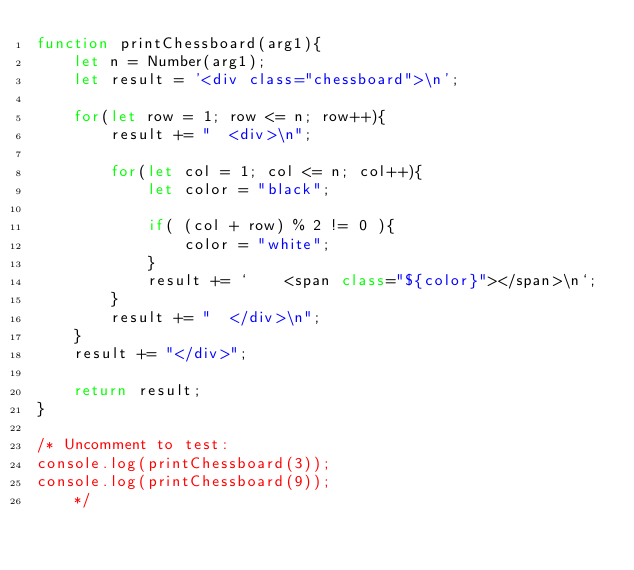<code> <loc_0><loc_0><loc_500><loc_500><_JavaScript_>function printChessboard(arg1){
    let n = Number(arg1);
    let result = '<div class="chessboard">\n';

    for(let row = 1; row <= n; row++){
        result += "  <div>\n";

        for(let col = 1; col <= n; col++){
            let color = "black";

            if( (col + row) % 2 != 0 ){
                color = "white";
            }
            result += `    <span class="${color}"></span>\n`;
        }
        result += "  </div>\n";
    }
    result += "</div>";

    return result;
}

/* Uncomment to test:
console.log(printChessboard(3));
console.log(printChessboard(9));
    */</code> 